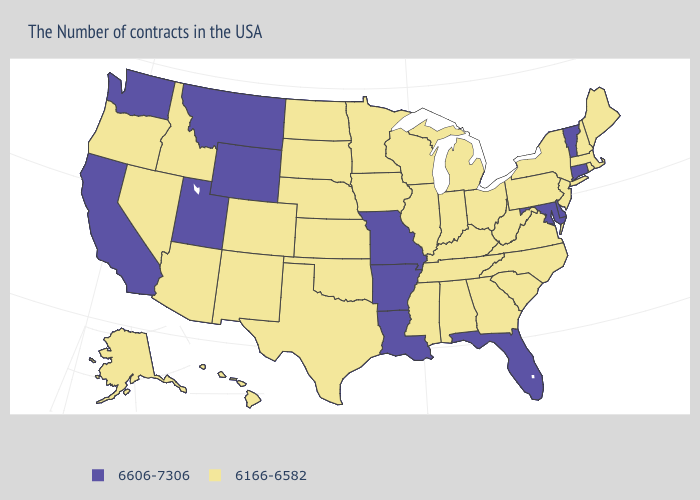Name the states that have a value in the range 6166-6582?
Write a very short answer. Maine, Massachusetts, Rhode Island, New Hampshire, New York, New Jersey, Pennsylvania, Virginia, North Carolina, South Carolina, West Virginia, Ohio, Georgia, Michigan, Kentucky, Indiana, Alabama, Tennessee, Wisconsin, Illinois, Mississippi, Minnesota, Iowa, Kansas, Nebraska, Oklahoma, Texas, South Dakota, North Dakota, Colorado, New Mexico, Arizona, Idaho, Nevada, Oregon, Alaska, Hawaii. Name the states that have a value in the range 6166-6582?
Short answer required. Maine, Massachusetts, Rhode Island, New Hampshire, New York, New Jersey, Pennsylvania, Virginia, North Carolina, South Carolina, West Virginia, Ohio, Georgia, Michigan, Kentucky, Indiana, Alabama, Tennessee, Wisconsin, Illinois, Mississippi, Minnesota, Iowa, Kansas, Nebraska, Oklahoma, Texas, South Dakota, North Dakota, Colorado, New Mexico, Arizona, Idaho, Nevada, Oregon, Alaska, Hawaii. Among the states that border Michigan , which have the lowest value?
Be succinct. Ohio, Indiana, Wisconsin. What is the value of Utah?
Give a very brief answer. 6606-7306. What is the value of Oregon?
Concise answer only. 6166-6582. Among the states that border Virginia , which have the lowest value?
Concise answer only. North Carolina, West Virginia, Kentucky, Tennessee. Is the legend a continuous bar?
Quick response, please. No. Name the states that have a value in the range 6166-6582?
Be succinct. Maine, Massachusetts, Rhode Island, New Hampshire, New York, New Jersey, Pennsylvania, Virginia, North Carolina, South Carolina, West Virginia, Ohio, Georgia, Michigan, Kentucky, Indiana, Alabama, Tennessee, Wisconsin, Illinois, Mississippi, Minnesota, Iowa, Kansas, Nebraska, Oklahoma, Texas, South Dakota, North Dakota, Colorado, New Mexico, Arizona, Idaho, Nevada, Oregon, Alaska, Hawaii. Does Vermont have the highest value in the Northeast?
Quick response, please. Yes. What is the lowest value in the MidWest?
Keep it brief. 6166-6582. What is the highest value in the USA?
Concise answer only. 6606-7306. What is the value of New Hampshire?
Write a very short answer. 6166-6582. Does the first symbol in the legend represent the smallest category?
Quick response, please. No. Among the states that border Mississippi , which have the lowest value?
Keep it brief. Alabama, Tennessee. What is the value of Montana?
Concise answer only. 6606-7306. 